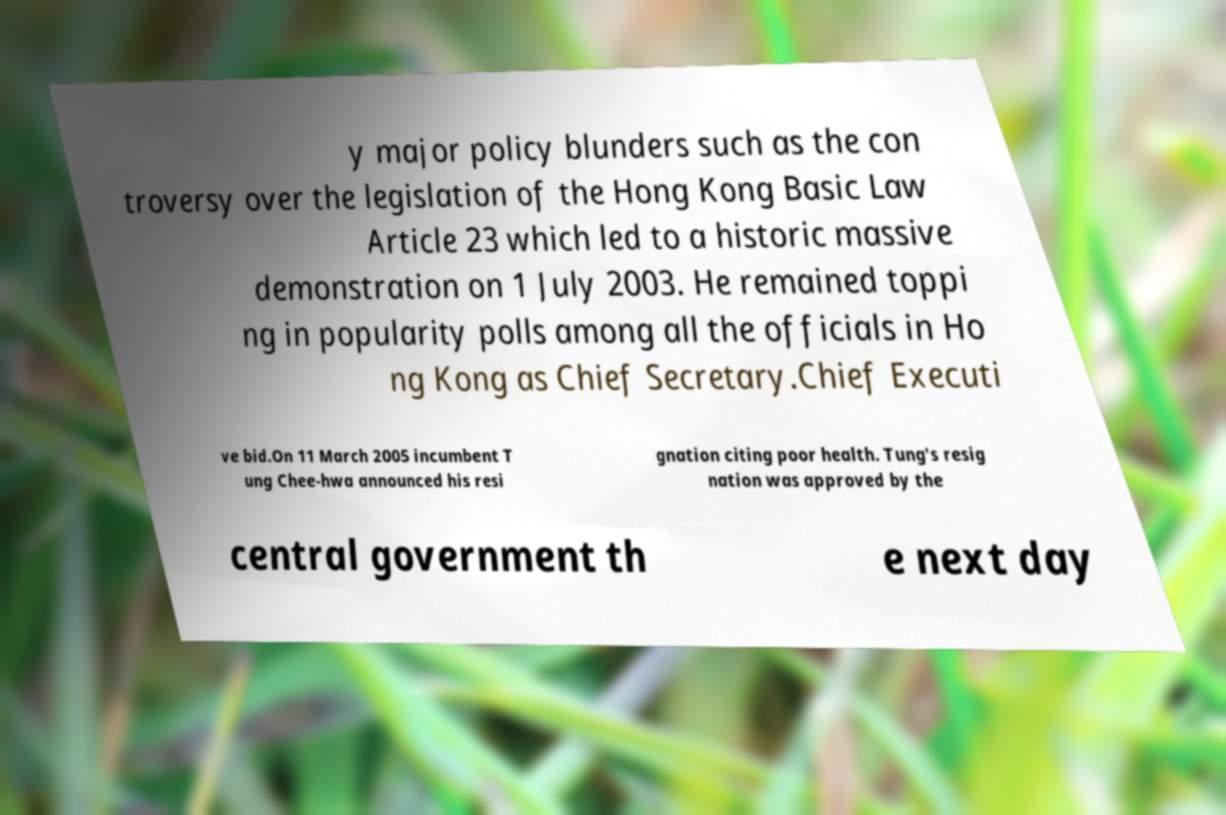Please read and relay the text visible in this image. What does it say? y major policy blunders such as the con troversy over the legislation of the Hong Kong Basic Law Article 23 which led to a historic massive demonstration on 1 July 2003. He remained toppi ng in popularity polls among all the officials in Ho ng Kong as Chief Secretary.Chief Executi ve bid.On 11 March 2005 incumbent T ung Chee-hwa announced his resi gnation citing poor health. Tung's resig nation was approved by the central government th e next day 